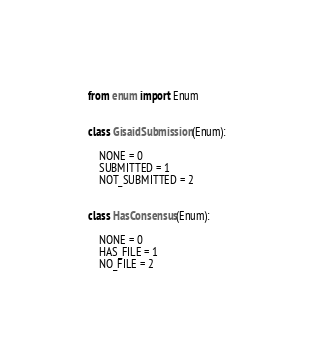<code> <loc_0><loc_0><loc_500><loc_500><_Python_>from enum import Enum


class GisaidSubmission(Enum):

    NONE = 0
    SUBMITTED = 1
    NOT_SUBMITTED = 2


class HasConsensus(Enum):

    NONE = 0
    HAS_FILE = 1
    NO_FILE = 2
</code> 